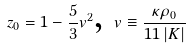Convert formula to latex. <formula><loc_0><loc_0><loc_500><loc_500>z _ { 0 } = 1 - \frac { 5 } { 3 } v ^ { 2 } \text {, } v \equiv \frac { \kappa \rho _ { 0 } } { 1 1 \left | K \right | }</formula> 